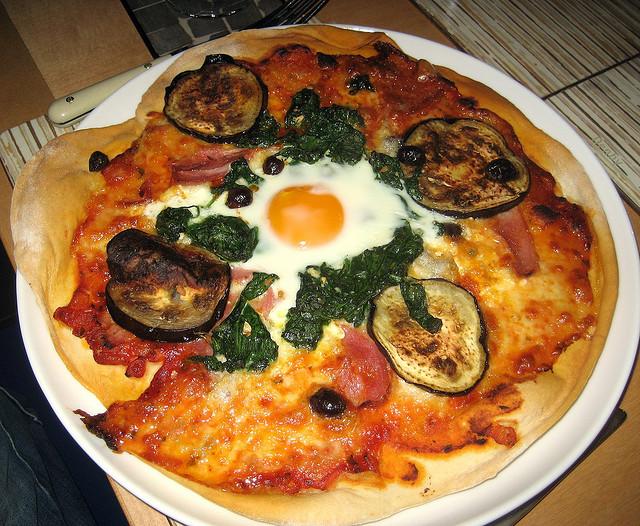What are the four large vegetable slices from?
Keep it brief. Eggplant. What are the round black items on the pizza?
Keep it brief. Olives. What shape is the plate the pizza is on?
Write a very short answer. Round. Is the egg cooked?
Concise answer only. Yes. 